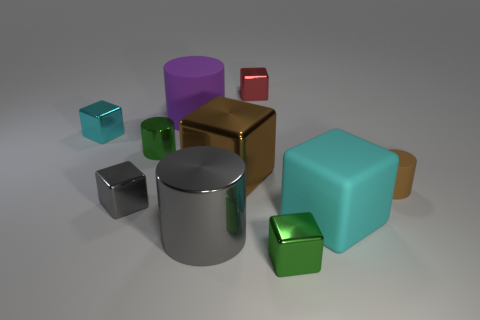Subtract all small green metallic cubes. How many cubes are left? 5 Subtract all brown blocks. How many blocks are left? 5 Subtract all red blocks. Subtract all gray cylinders. How many blocks are left? 5 Subtract all blocks. How many objects are left? 4 Add 3 cyan matte objects. How many cyan matte objects exist? 4 Subtract 0 brown balls. How many objects are left? 10 Subtract all green objects. Subtract all large matte cylinders. How many objects are left? 7 Add 4 big metallic cubes. How many big metallic cubes are left? 5 